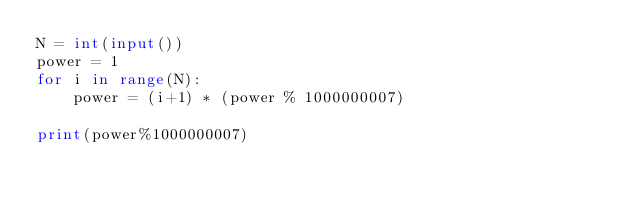Convert code to text. <code><loc_0><loc_0><loc_500><loc_500><_Python_>N = int(input())
power = 1
for i in range(N):
    power = (i+1) * (power % 1000000007)

print(power%1000000007)
</code> 